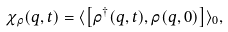Convert formula to latex. <formula><loc_0><loc_0><loc_500><loc_500>\chi _ { \rho } ( q , t ) = \langle \left [ \rho ^ { \dagger } ( q , t ) , \rho ( q , 0 ) \right ] \rangle _ { 0 } ,</formula> 